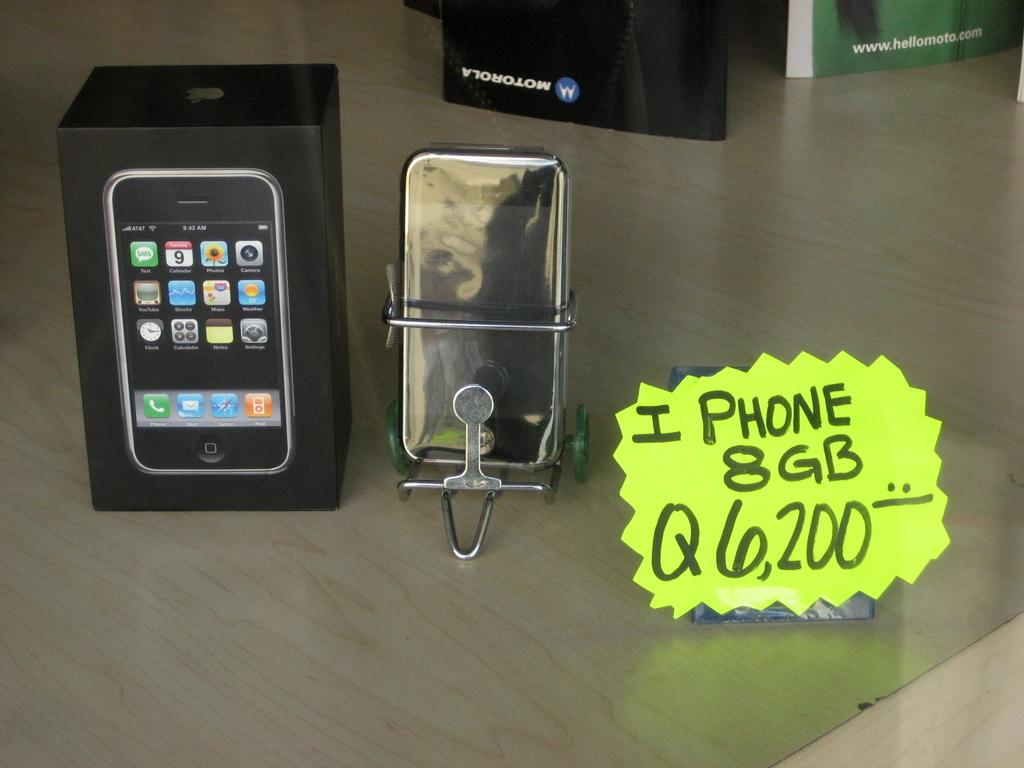Provide a one-sentence caption for the provided image. sign for iphone 8 g it looks like an old model. 